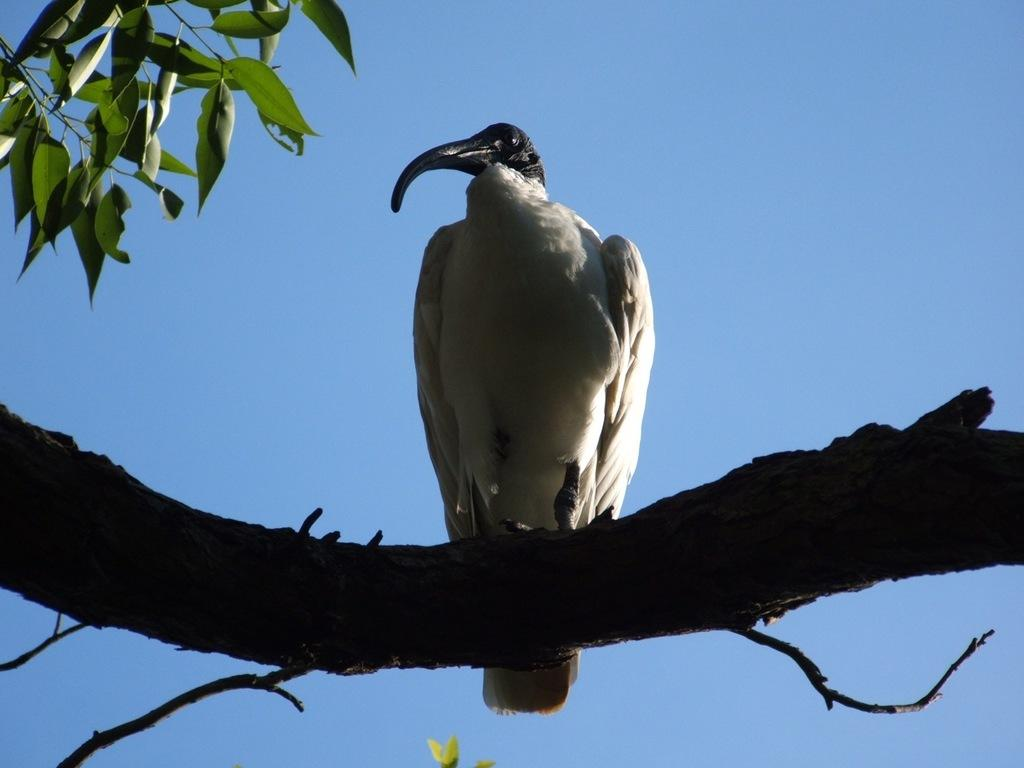What type of animal can be seen in the image? There is a bird in the image. Where is the bird located? The bird is on a tree branch. What other elements can be seen in the image besides the bird? There are stems and leaves visible in the image. What is visible in the background of the image? The sky is visible in the background of the image. What type of fruit is hanging from the tree branch in the image? There is no fruit visible in the image; only a bird, stems, leaves, and the sky are present. 